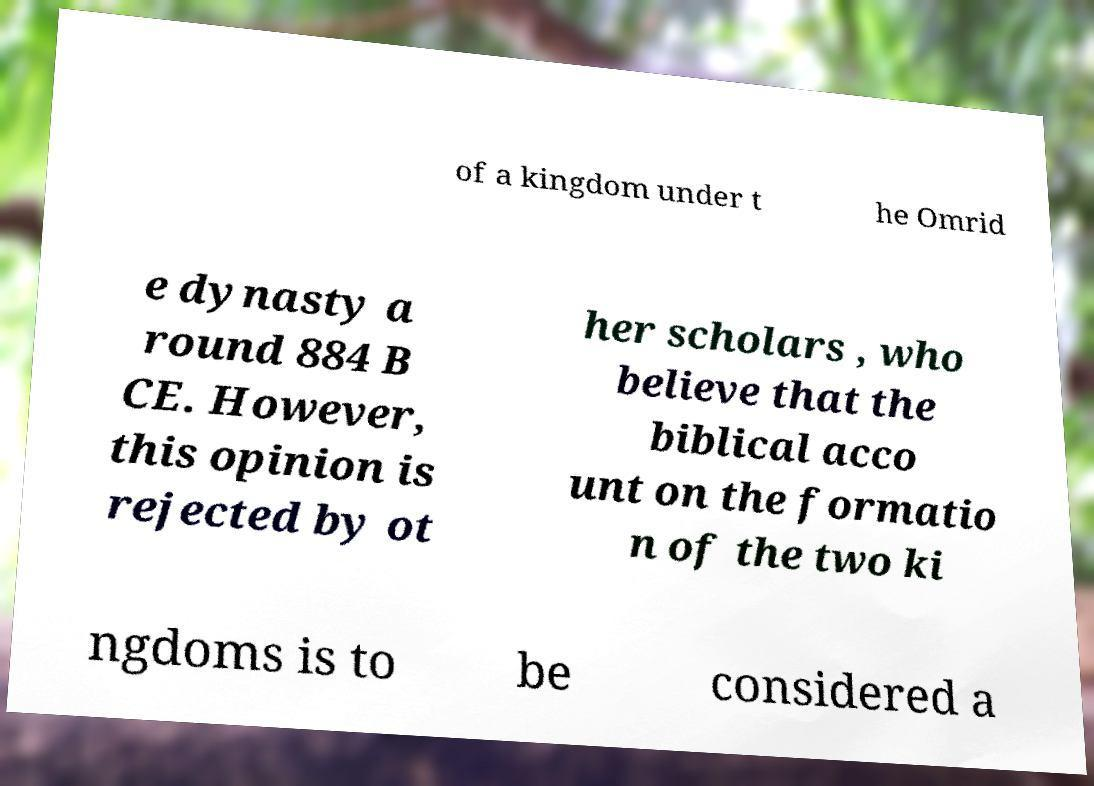There's text embedded in this image that I need extracted. Can you transcribe it verbatim? of a kingdom under t he Omrid e dynasty a round 884 B CE. However, this opinion is rejected by ot her scholars , who believe that the biblical acco unt on the formatio n of the two ki ngdoms is to be considered a 